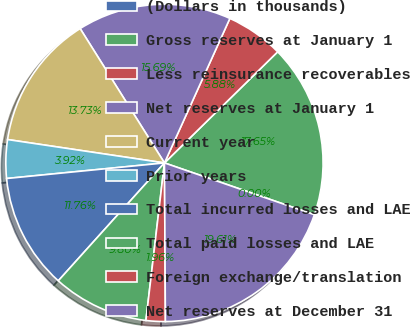Convert chart. <chart><loc_0><loc_0><loc_500><loc_500><pie_chart><fcel>(Dollars in thousands)<fcel>Gross reserves at January 1<fcel>Less reinsurance recoverables<fcel>Net reserves at January 1<fcel>Current year<fcel>Prior years<fcel>Total incurred losses and LAE<fcel>Total paid losses and LAE<fcel>Foreign exchange/translation<fcel>Net reserves at December 31<nl><fcel>0.0%<fcel>17.64%<fcel>5.88%<fcel>15.68%<fcel>13.72%<fcel>3.92%<fcel>11.76%<fcel>9.8%<fcel>1.96%<fcel>19.6%<nl></chart> 